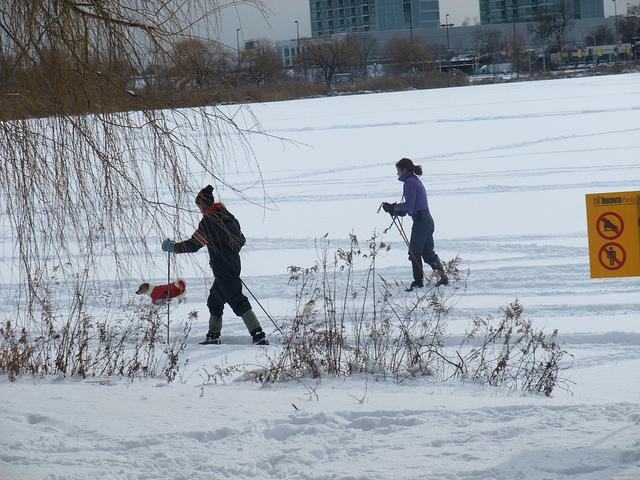What is the first activity that is not allowed on the ice? skating 